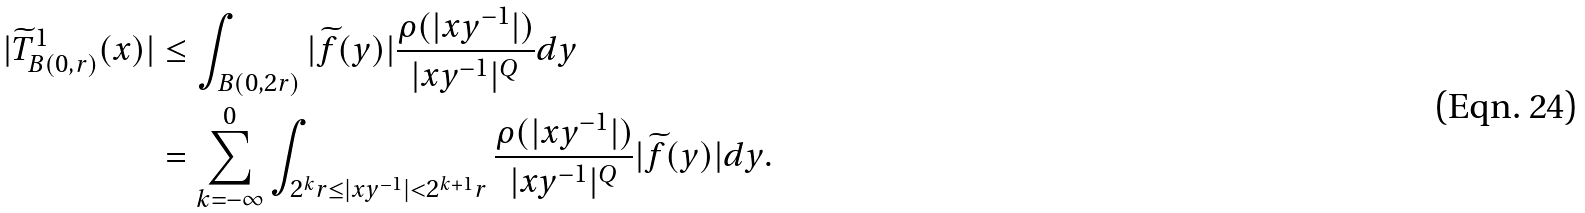<formula> <loc_0><loc_0><loc_500><loc_500>| \widetilde { T } ^ { 1 } _ { B ( 0 , r ) } ( x ) | & \leq \int _ { B ( 0 , 2 r ) } | \widetilde { f } ( y ) | \frac { \rho ( | x y ^ { - 1 } | ) } { | x y ^ { - 1 } | ^ { Q } } d y \\ & = \sum _ { k = - \infty } ^ { 0 } \int _ { 2 ^ { k } r \leq | x y ^ { - 1 } | < 2 ^ { k + 1 } r } \frac { \rho ( | x y ^ { - 1 } | ) } { | x y ^ { - 1 } | ^ { Q } } | \widetilde { f } ( y ) | d y .</formula> 